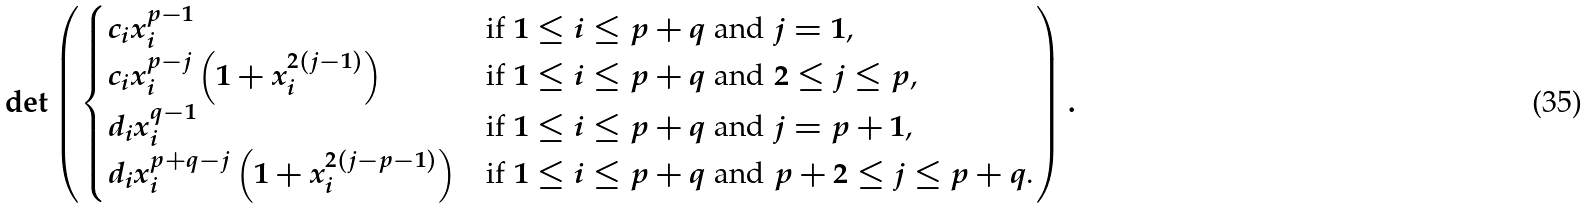Convert formula to latex. <formula><loc_0><loc_0><loc_500><loc_500>\det \left ( \begin{cases} c _ { i } x _ { i } ^ { p - 1 } & \text {if $1 \leq i \leq p+q$ and $j = 1$,} \\ c _ { i } x _ { i } ^ { p - j } \left ( 1 + x _ { i } ^ { 2 ( j - 1 ) } \right ) & \text {if $1 \leq i \leq p+q$ and $2 \leq j \leq p$,} \\ d _ { i } x _ { i } ^ { q - 1 } & \text {if $1 \leq i \leq p+q$ and $j = p+1$,} \\ d _ { i } x _ { i } ^ { p + q - j } \left ( 1 + x _ { i } ^ { 2 ( j - p - 1 ) } \right ) & \text {if $1 \leq i \leq p+q$ and $p+2 \leq j \leq p+q$.} \end{cases} \right ) .</formula> 